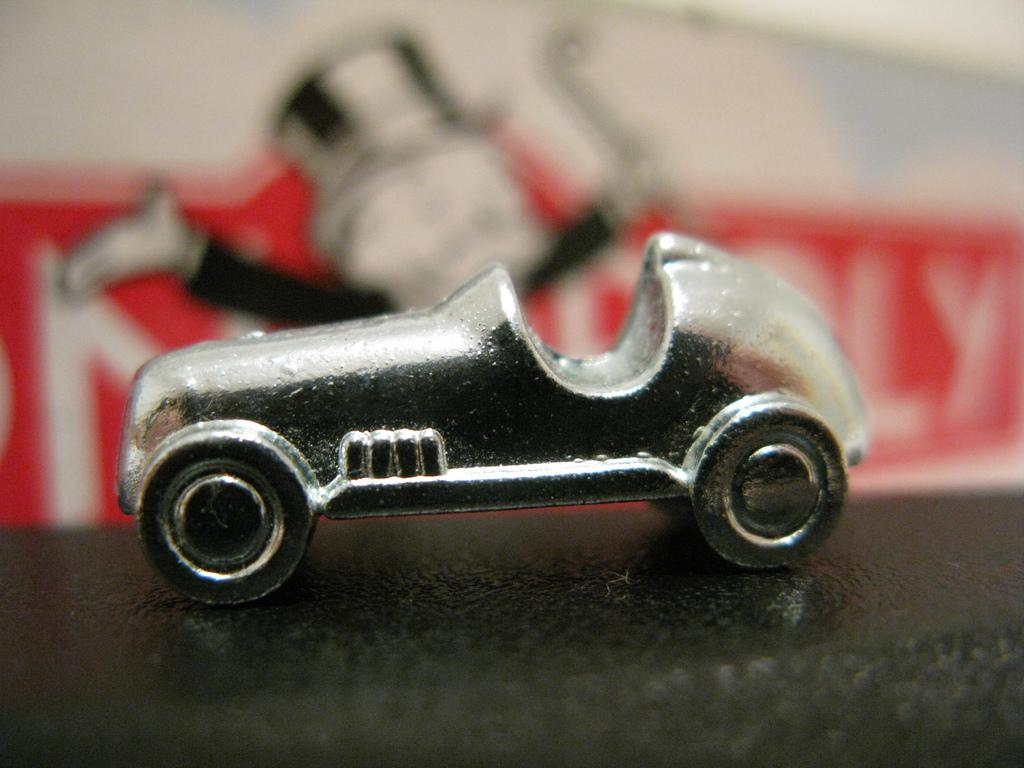What type of toy is visible in the image? There is a toy car in the image. Where is the toy car located? The toy car is placed on a surface in the image. What can be seen on the walls in the image? There is a picture and text on a wall in the image. What type of cake is being advertised on the wall in the image? There is no cake or advertisement present in the image; only a toy car, a surface, a picture, and text on a wall are visible. 